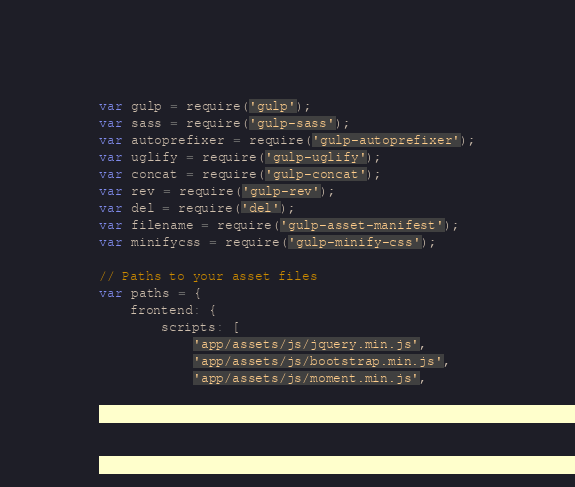Convert code to text. <code><loc_0><loc_0><loc_500><loc_500><_JavaScript_>var gulp = require('gulp');
var sass = require('gulp-sass');
var autoprefixer = require('gulp-autoprefixer');
var uglify = require('gulp-uglify');
var concat = require('gulp-concat');
var rev = require('gulp-rev');
var del = require('del');
var filename = require('gulp-asset-manifest');
var minifycss = require('gulp-minify-css');

// Paths to your asset files
var paths = {
    frontend: {
        scripts: [
            'app/assets/js/jquery.min.js',
            'app/assets/js/bootstrap.min.js',
            'app/assets/js/moment.min.js',</code> 